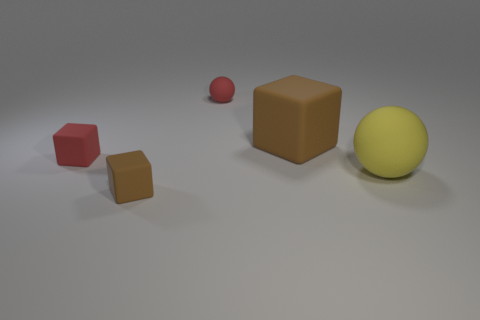Add 1 red matte objects. How many objects exist? 6 Subtract all cubes. How many objects are left? 2 Add 2 big brown blocks. How many big brown blocks are left? 3 Add 3 tiny green matte objects. How many tiny green matte objects exist? 3 Subtract 0 brown cylinders. How many objects are left? 5 Subtract all blocks. Subtract all big yellow things. How many objects are left? 1 